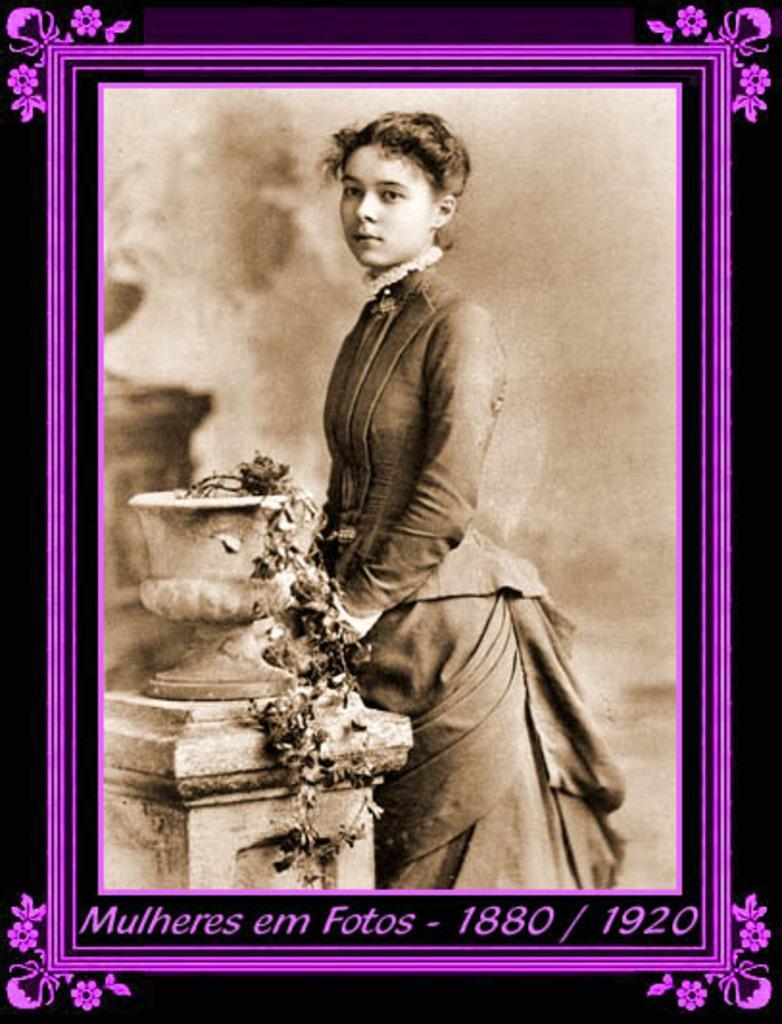Can you describe this image briefly? This image contains a picture frame. In the picture there is a woman standing near the pillar having pot on it. Pot is having a plant in it. 